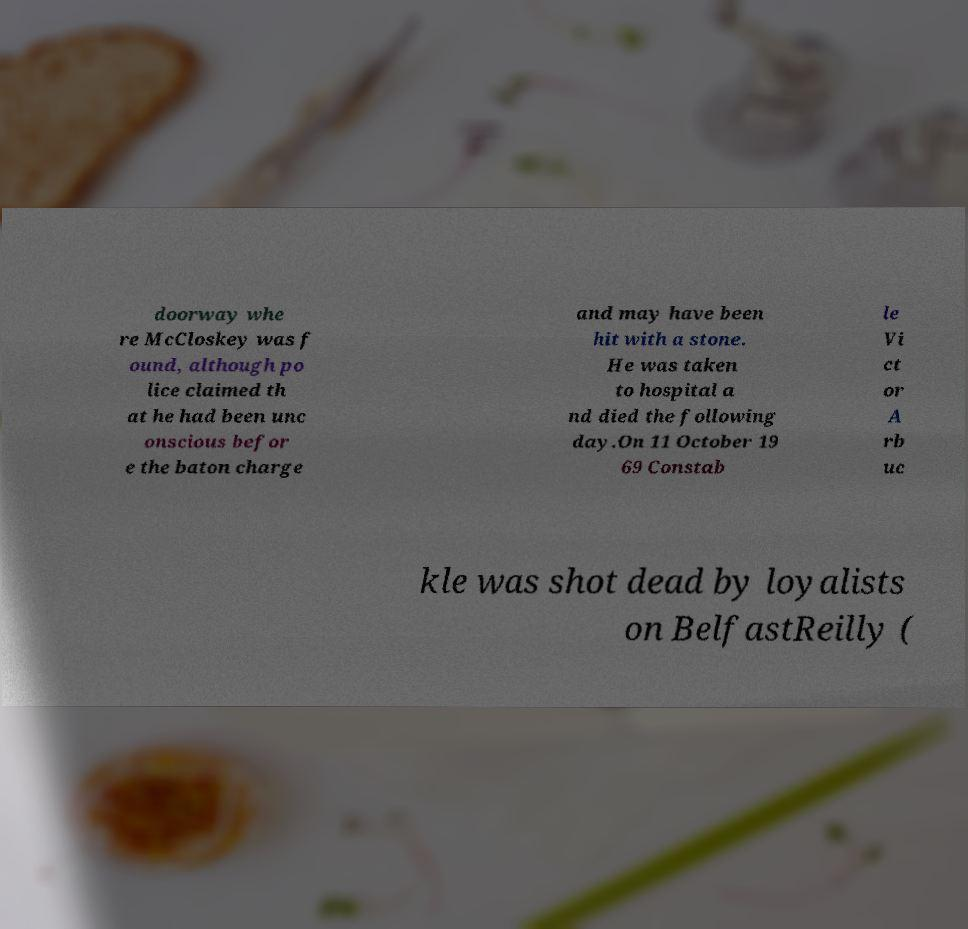Can you accurately transcribe the text from the provided image for me? doorway whe re McCloskey was f ound, although po lice claimed th at he had been unc onscious befor e the baton charge and may have been hit with a stone. He was taken to hospital a nd died the following day.On 11 October 19 69 Constab le Vi ct or A rb uc kle was shot dead by loyalists on BelfastReilly ( 